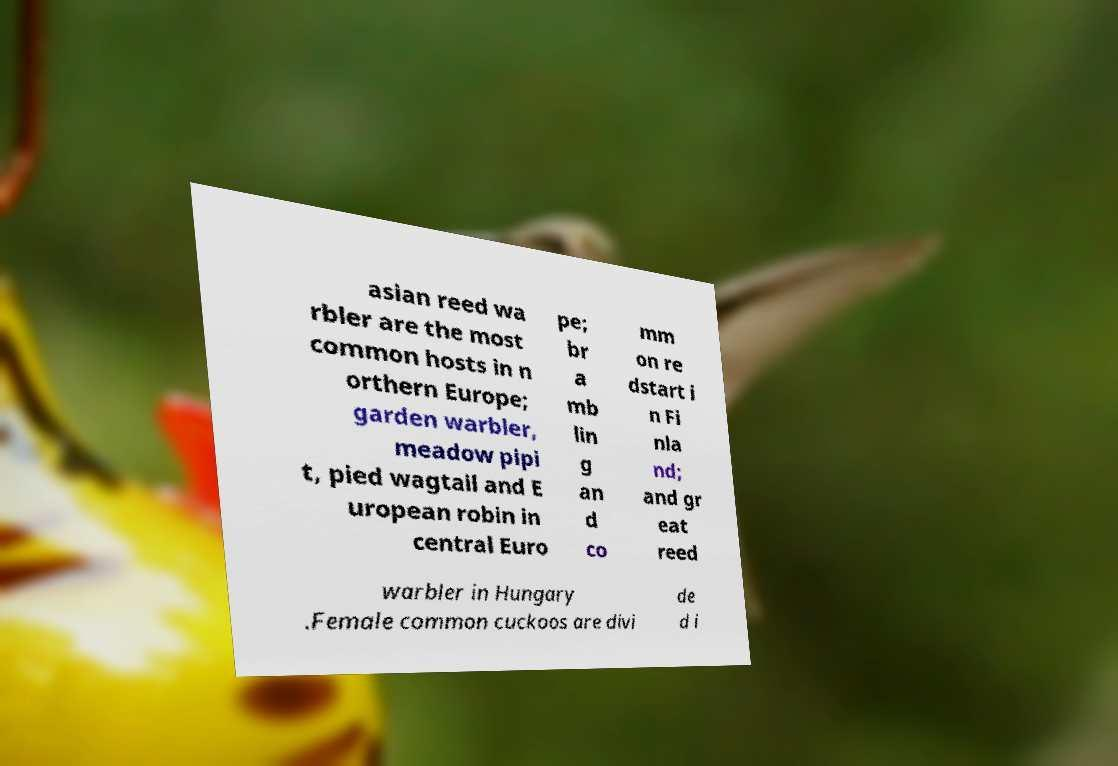Please identify and transcribe the text found in this image. asian reed wa rbler are the most common hosts in n orthern Europe; garden warbler, meadow pipi t, pied wagtail and E uropean robin in central Euro pe; br a mb lin g an d co mm on re dstart i n Fi nla nd; and gr eat reed warbler in Hungary .Female common cuckoos are divi de d i 